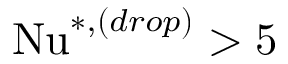Convert formula to latex. <formula><loc_0><loc_0><loc_500><loc_500>N u ^ { * , ( d r o p ) } > 5</formula> 